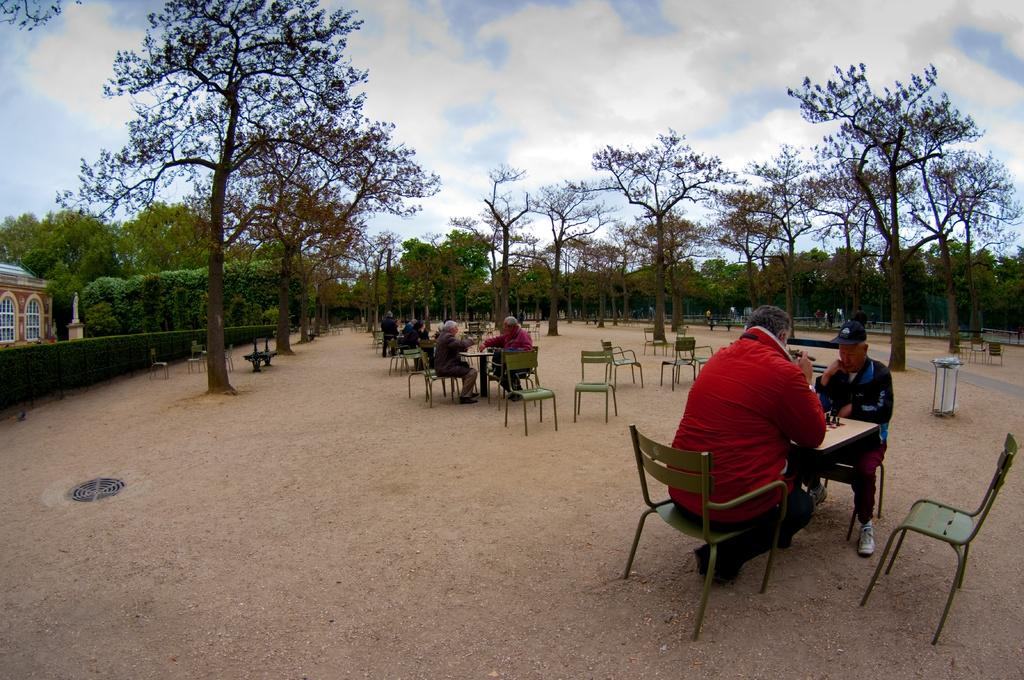What type of setting is shown in the image? The image depicts an open area. What furniture is present in the open area? There are tables and chairs in the open area. What are the people in the image doing? People are sitting on the chairs. What can be seen in the background of the image? There are trees visible in the background. What structure is located on the left side of the image? There is a building on the left side of the image. How many bulbs are hanging from the trees in the image? There are no bulbs hanging from the trees in the image; only trees are visible in the background. Why are the people in the image crying? There is no indication in the image that the people are crying; they are simply sitting on the chairs. 